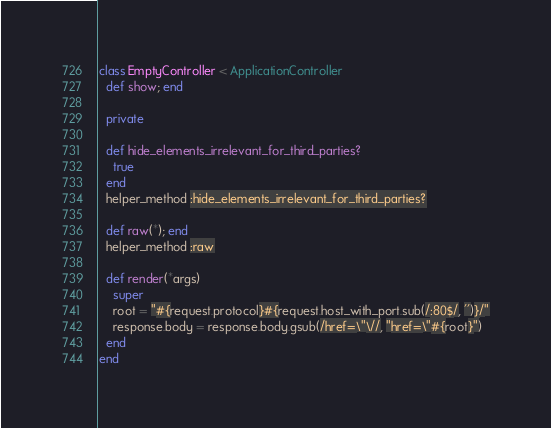Convert code to text. <code><loc_0><loc_0><loc_500><loc_500><_Ruby_>class EmptyController < ApplicationController
  def show; end

  private

  def hide_elements_irrelevant_for_third_parties?
    true
  end
  helper_method :hide_elements_irrelevant_for_third_parties?

  def raw(*); end
  helper_method :raw

  def render(*args)
    super
    root = "#{request.protocol}#{request.host_with_port.sub(/:80$/, '')}/"
    response.body = response.body.gsub(/href=\"\//, "href=\"#{root}")
  end
end
</code> 